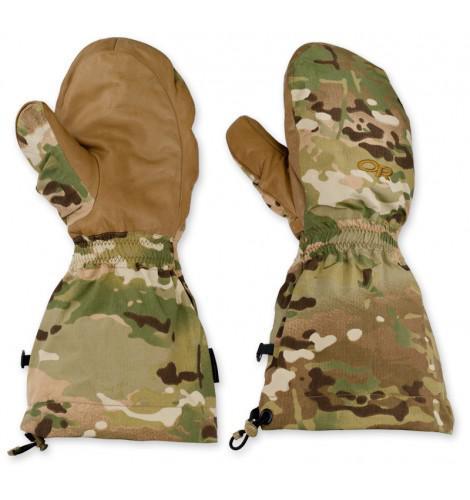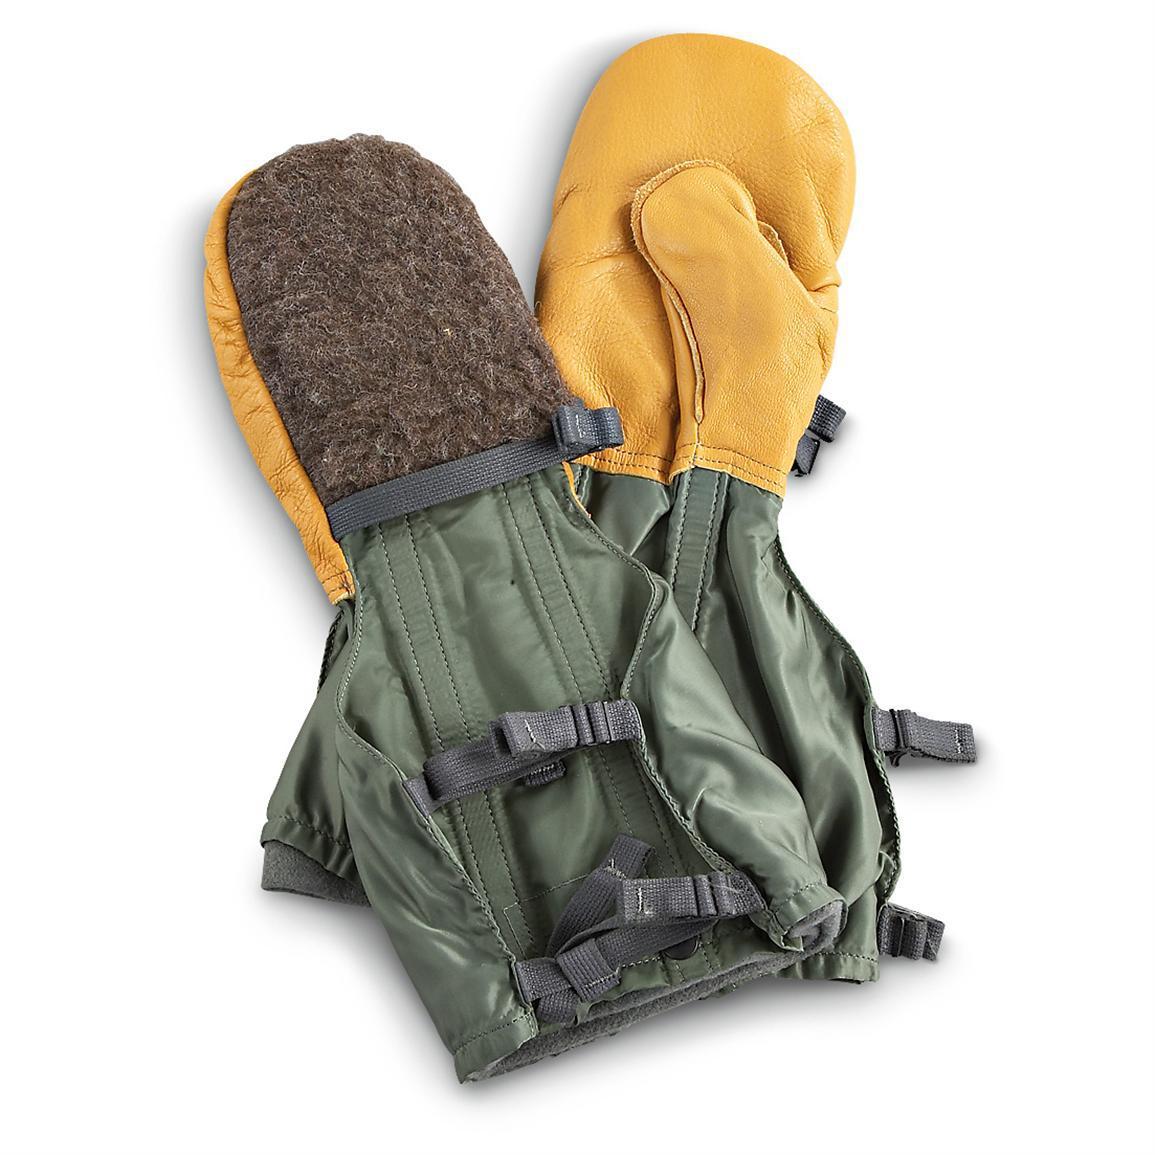The first image is the image on the left, the second image is the image on the right. For the images shown, is this caption "Two of the gloves can be seen to have a woodland camouflage pattern." true? Answer yes or no. Yes. The first image is the image on the left, the second image is the image on the right. Given the left and right images, does the statement "One image shows a pair of mittens with half-fingers exposed on one mitt only." hold true? Answer yes or no. No. 